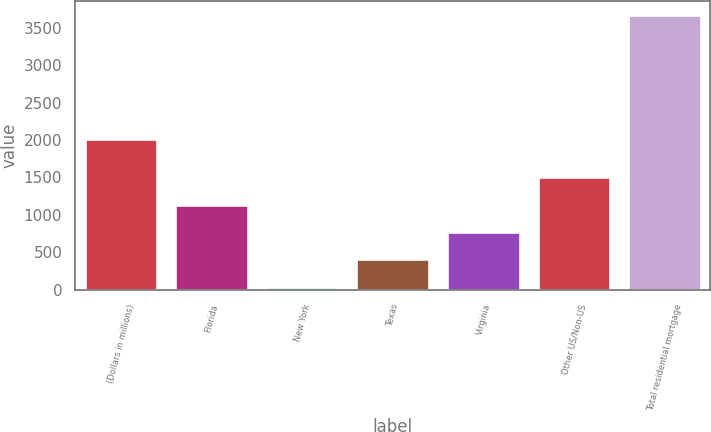<chart> <loc_0><loc_0><loc_500><loc_500><bar_chart><fcel>(Dollars in millions)<fcel>Florida<fcel>New York<fcel>Texas<fcel>Virginia<fcel>Other US/Non-US<fcel>Total residential mortgage<nl><fcel>2010<fcel>1131.8<fcel>44<fcel>406.6<fcel>769.2<fcel>1506<fcel>3670<nl></chart> 